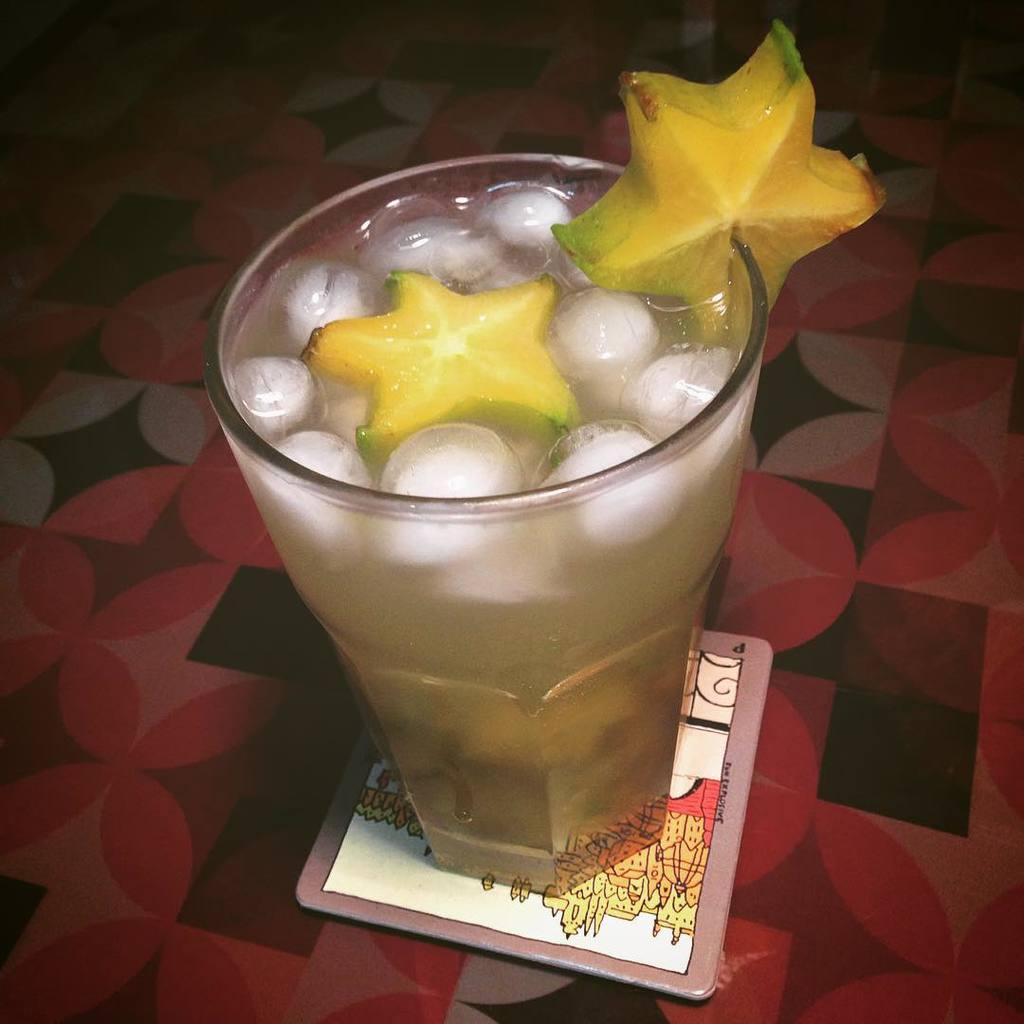What is the main object in the center of the picture? There is a glass in the center of the picture. What is inside the glass? The glass contains a drink with ice cubes and a fruit. What is the surface beneath the glass? There is a table at the bottom of the image. What grade does the fruit in the glass receive for its performance in the image? The fruit in the glass is not performing anything, so it cannot receive a grade. 